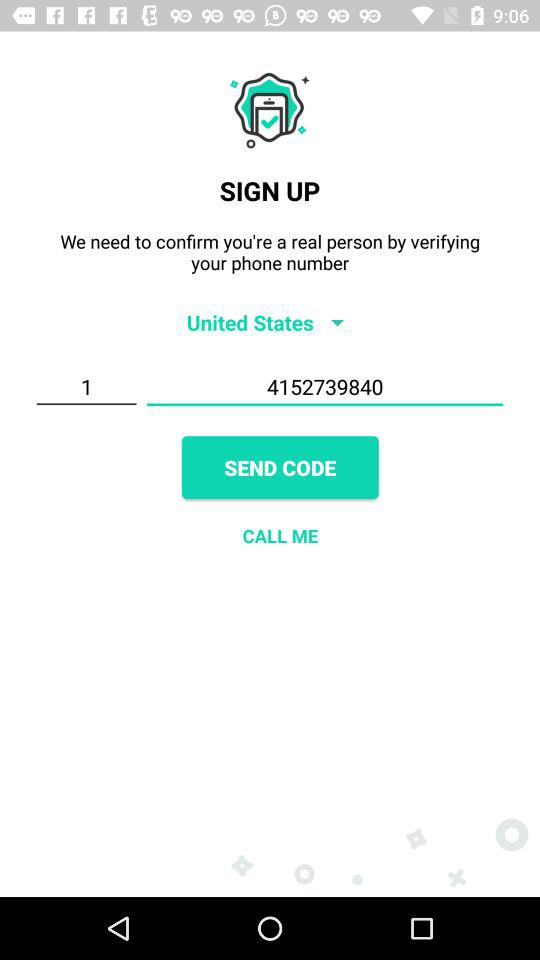What is the country code of the entered number? The country code of the entered number is 1. 